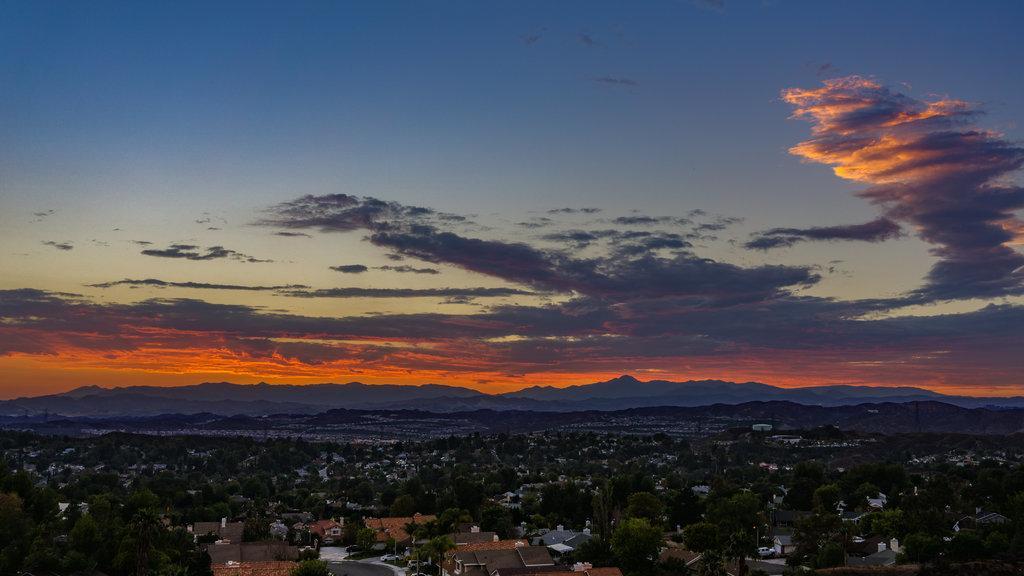How would you summarize this image in a sentence or two? Here in this picture we can see an Aerial view, through which we can see buildings and houses present on the ground and we can also see plants and trees present and in the far we can see mountains present and we can see clouds in the sky. 